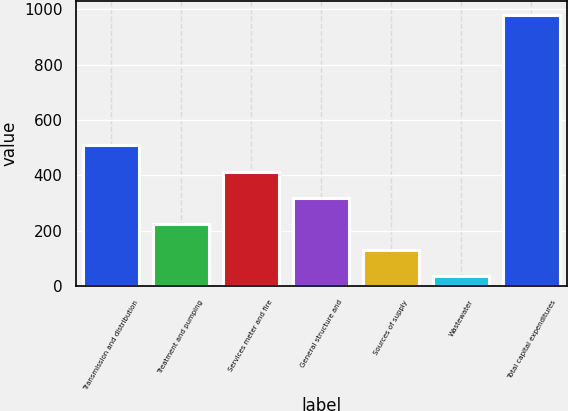Convert chart. <chart><loc_0><loc_0><loc_500><loc_500><bar_chart><fcel>Transmission and distribution<fcel>Treatment and pumping<fcel>Services meter and fire<fcel>General structure and<fcel>Sources of supply<fcel>Wastewater<fcel>Total capital expenditures<nl><fcel>508<fcel>224.8<fcel>413.6<fcel>319.2<fcel>130.4<fcel>36<fcel>980<nl></chart> 